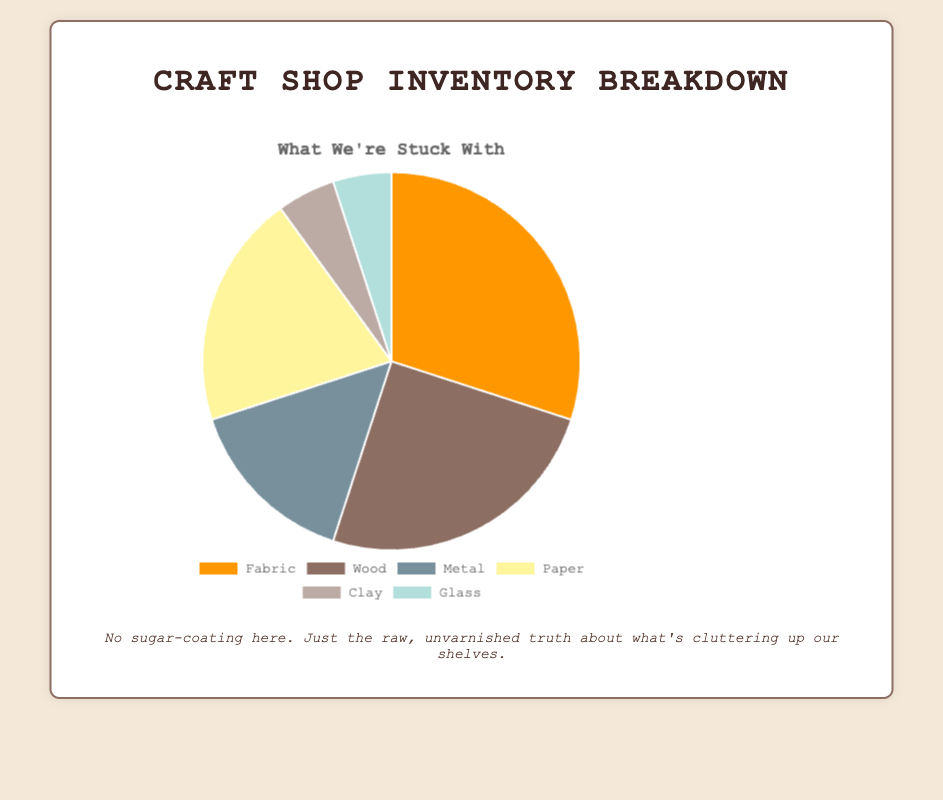What material type makes up the largest percentage of the inventory? The largest percentage is 30%. By looking at all the categories, Fabric has the highest percentage.
Answer: Fabric How much more percentage of the inventory is composed of Fabric than Metal? Fabric comprises 30% and Metal 15%. To find the difference, subtract 15 from 30: 30% - 15% = 15%.
Answer: 15% What percentage of the inventory is made up of Clay and Glass combined? Clay is 5% and Glass is 5%. Adding them together, 5% + 5% = 10%.
Answer: 10% Which material type has the lowest percentage in the inventory, and what is that percentage? Both Clay and Glass have the lowest percentages, each at 5%.
Answer: Clay and Glass, 5% Is the percentage of Paper in the inventory greater than the percentage of Wood? Paper is 20% and Wood is 25%. Thus, Wood is greater.
Answer: No How many material types make up at least 20% of the inventory each? Fabric is 30%, Wood is 25%, and Paper is 20%. Count them: 3 material types.
Answer: 3 What is the average percentage of the inventory for the materials Wood and Paper? Wood is 25% and Paper is 20%. The average percentage is (25% + 20%) / 2 = 22.5%.
Answer: 22.5% Which materials share the same percentage of the inventory, and what color are they represented by in the chart? Clay and Glass both are 5%. Clay is typically represented by a beige-like color and Glass by a teal-like color.
Answer: Clay and Glass, beige and teal If you combine Fabric, Wood, and Paper, what percentage of the total inventory do they make up? Add Fabric (30%), Wood (25%), and Paper (20%): 30% + 25% + 20% = 75%.
Answer: 75% Is Metal's percentage in the inventory more than the combined percentage of Clay and Glass? Metal is 15%, and the combined percentage of Clay and Glass is 5% + 5% = 10%. Hence, Metal's percentage is more.
Answer: Yes 